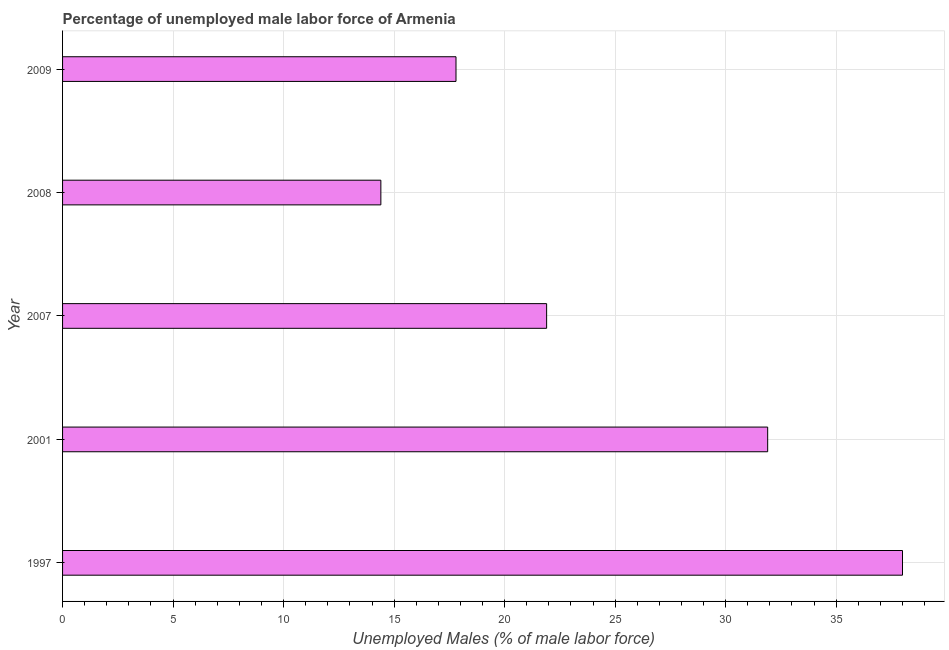Does the graph contain any zero values?
Offer a terse response. No. What is the title of the graph?
Ensure brevity in your answer.  Percentage of unemployed male labor force of Armenia. What is the label or title of the X-axis?
Your answer should be very brief. Unemployed Males (% of male labor force). What is the label or title of the Y-axis?
Ensure brevity in your answer.  Year. What is the total unemployed male labour force in 2008?
Offer a terse response. 14.4. Across all years, what is the minimum total unemployed male labour force?
Your answer should be compact. 14.4. In which year was the total unemployed male labour force minimum?
Provide a short and direct response. 2008. What is the sum of the total unemployed male labour force?
Keep it short and to the point. 124. What is the average total unemployed male labour force per year?
Ensure brevity in your answer.  24.8. What is the median total unemployed male labour force?
Your response must be concise. 21.9. Do a majority of the years between 2009 and 1997 (inclusive) have total unemployed male labour force greater than 8 %?
Offer a very short reply. Yes. What is the ratio of the total unemployed male labour force in 2001 to that in 2007?
Your response must be concise. 1.46. Is the difference between the total unemployed male labour force in 2001 and 2007 greater than the difference between any two years?
Ensure brevity in your answer.  No. Is the sum of the total unemployed male labour force in 2001 and 2007 greater than the maximum total unemployed male labour force across all years?
Offer a very short reply. Yes. What is the difference between the highest and the lowest total unemployed male labour force?
Give a very brief answer. 23.6. Are all the bars in the graph horizontal?
Provide a succinct answer. Yes. What is the Unemployed Males (% of male labor force) of 2001?
Your response must be concise. 31.9. What is the Unemployed Males (% of male labor force) in 2007?
Offer a very short reply. 21.9. What is the Unemployed Males (% of male labor force) of 2008?
Provide a succinct answer. 14.4. What is the Unemployed Males (% of male labor force) in 2009?
Your response must be concise. 17.8. What is the difference between the Unemployed Males (% of male labor force) in 1997 and 2001?
Make the answer very short. 6.1. What is the difference between the Unemployed Males (% of male labor force) in 1997 and 2008?
Your answer should be very brief. 23.6. What is the difference between the Unemployed Males (% of male labor force) in 1997 and 2009?
Keep it short and to the point. 20.2. What is the difference between the Unemployed Males (% of male labor force) in 2001 and 2007?
Offer a very short reply. 10. What is the difference between the Unemployed Males (% of male labor force) in 2001 and 2008?
Offer a terse response. 17.5. What is the difference between the Unemployed Males (% of male labor force) in 2007 and 2008?
Offer a terse response. 7.5. What is the difference between the Unemployed Males (% of male labor force) in 2007 and 2009?
Your answer should be very brief. 4.1. What is the difference between the Unemployed Males (% of male labor force) in 2008 and 2009?
Ensure brevity in your answer.  -3.4. What is the ratio of the Unemployed Males (% of male labor force) in 1997 to that in 2001?
Your answer should be compact. 1.19. What is the ratio of the Unemployed Males (% of male labor force) in 1997 to that in 2007?
Provide a succinct answer. 1.74. What is the ratio of the Unemployed Males (% of male labor force) in 1997 to that in 2008?
Offer a very short reply. 2.64. What is the ratio of the Unemployed Males (% of male labor force) in 1997 to that in 2009?
Provide a short and direct response. 2.13. What is the ratio of the Unemployed Males (% of male labor force) in 2001 to that in 2007?
Provide a short and direct response. 1.46. What is the ratio of the Unemployed Males (% of male labor force) in 2001 to that in 2008?
Offer a terse response. 2.21. What is the ratio of the Unemployed Males (% of male labor force) in 2001 to that in 2009?
Your answer should be compact. 1.79. What is the ratio of the Unemployed Males (% of male labor force) in 2007 to that in 2008?
Provide a short and direct response. 1.52. What is the ratio of the Unemployed Males (% of male labor force) in 2007 to that in 2009?
Offer a terse response. 1.23. What is the ratio of the Unemployed Males (% of male labor force) in 2008 to that in 2009?
Offer a very short reply. 0.81. 